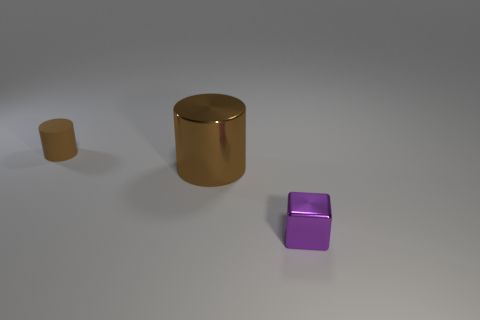Add 1 red shiny blocks. How many objects exist? 4 Subtract all cylinders. How many objects are left? 1 Subtract all gray rubber cylinders. Subtract all large brown objects. How many objects are left? 2 Add 3 purple things. How many purple things are left? 4 Add 2 purple things. How many purple things exist? 3 Subtract 0 cyan blocks. How many objects are left? 3 Subtract 1 blocks. How many blocks are left? 0 Subtract all red cylinders. Subtract all brown cubes. How many cylinders are left? 2 Subtract all cyan cylinders. How many gray cubes are left? 0 